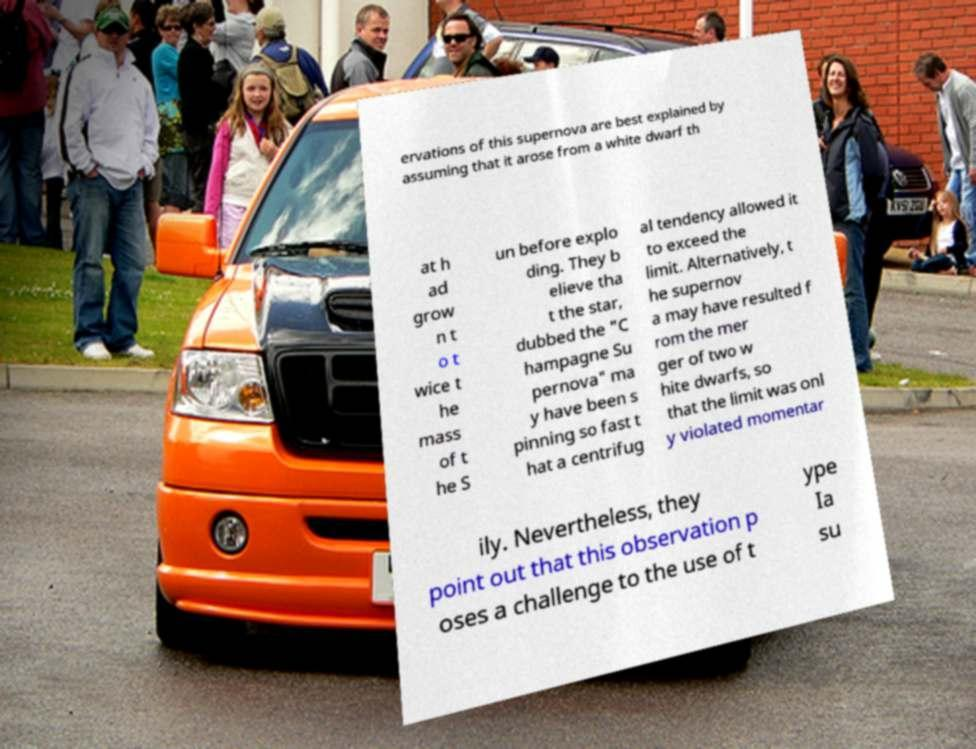There's text embedded in this image that I need extracted. Can you transcribe it verbatim? ervations of this supernova are best explained by assuming that it arose from a white dwarf th at h ad grow n t o t wice t he mass of t he S un before explo ding. They b elieve tha t the star, dubbed the "C hampagne Su pernova" ma y have been s pinning so fast t hat a centrifug al tendency allowed it to exceed the limit. Alternatively, t he supernov a may have resulted f rom the mer ger of two w hite dwarfs, so that the limit was onl y violated momentar ily. Nevertheless, they point out that this observation p oses a challenge to the use of t ype Ia su 